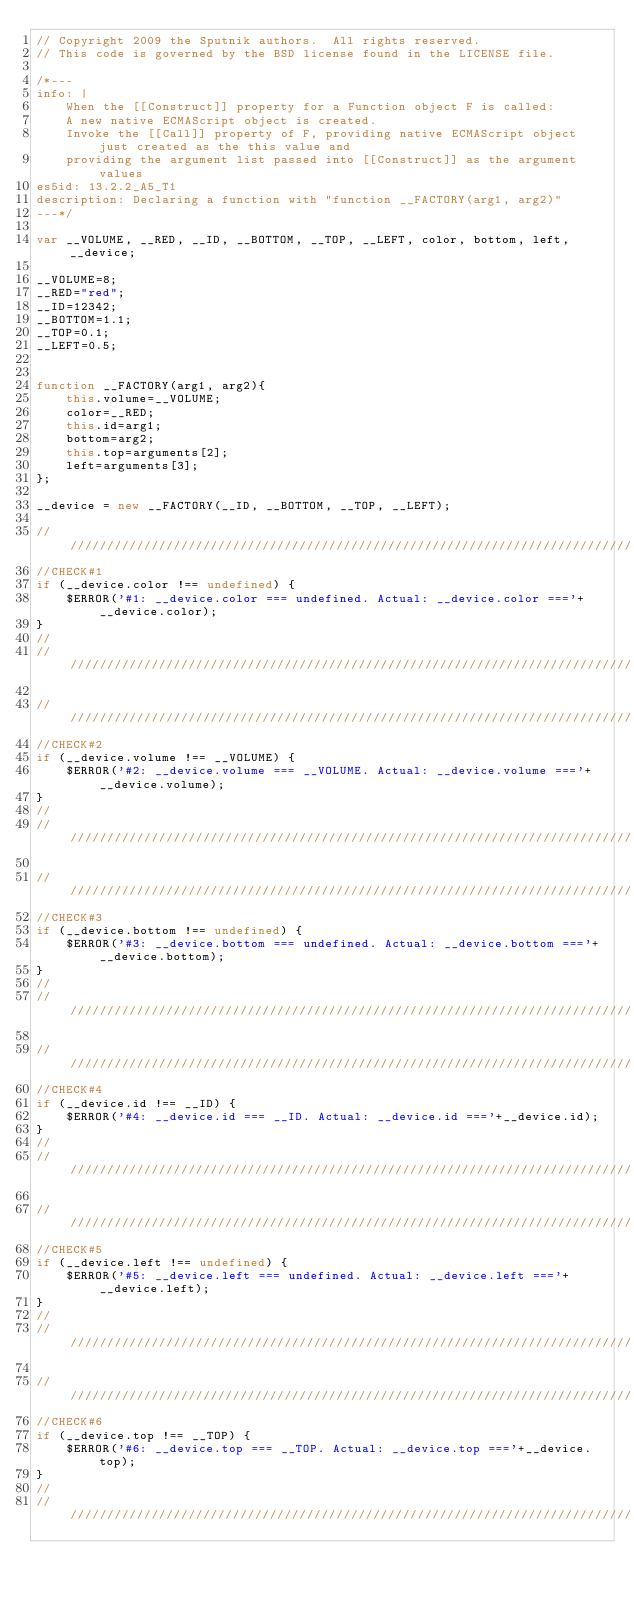Convert code to text. <code><loc_0><loc_0><loc_500><loc_500><_JavaScript_>// Copyright 2009 the Sputnik authors.  All rights reserved.
// This code is governed by the BSD license found in the LICENSE file.

/*---
info: |
    When the [[Construct]] property for a Function object F is called:
    A new native ECMAScript object is created.
    Invoke the [[Call]] property of F, providing native ECMAScript object just created as the this value and
    providing the argument list passed into [[Construct]] as the argument values
es5id: 13.2.2_A5_T1
description: Declaring a function with "function __FACTORY(arg1, arg2)"
---*/

var __VOLUME, __RED, __ID, __BOTTOM, __TOP, __LEFT, color, bottom, left, __device;

__VOLUME=8;
__RED="red";
__ID=12342;
__BOTTOM=1.1;
__TOP=0.1;
__LEFT=0.5;


function __FACTORY(arg1, arg2){
	this.volume=__VOLUME;
	color=__RED;
	this.id=arg1;
	bottom=arg2;
	this.top=arguments[2];
	left=arguments[3];
};

__device = new __FACTORY(__ID, __BOTTOM, __TOP, __LEFT);

//////////////////////////////////////////////////////////////////////////////
//CHECK#1
if (__device.color !== undefined) {
	$ERROR('#1: __device.color === undefined. Actual: __device.color ==='+__device.color);
}
//
//////////////////////////////////////////////////////////////////////////////

//////////////////////////////////////////////////////////////////////////////
//CHECK#2
if (__device.volume !== __VOLUME) {
	$ERROR('#2: __device.volume === __VOLUME. Actual: __device.volume ==='+__device.volume);
}
//
//////////////////////////////////////////////////////////////////////////////

//////////////////////////////////////////////////////////////////////////////
//CHECK#3
if (__device.bottom !== undefined) {
	$ERROR('#3: __device.bottom === undefined. Actual: __device.bottom ==='+__device.bottom);
}
//
//////////////////////////////////////////////////////////////////////////////

//////////////////////////////////////////////////////////////////////////////
//CHECK#4
if (__device.id !== __ID) {
	$ERROR('#4: __device.id === __ID. Actual: __device.id ==='+__device.id);
}
//
//////////////////////////////////////////////////////////////////////////////

//////////////////////////////////////////////////////////////////////////////
//CHECK#5
if (__device.left !== undefined) {
	$ERROR('#5: __device.left === undefined. Actual: __device.left ==='+__device.left);
}
//
//////////////////////////////////////////////////////////////////////////////

//////////////////////////////////////////////////////////////////////////////
//CHECK#6
if (__device.top !== __TOP) {
	$ERROR('#6: __device.top === __TOP. Actual: __device.top ==='+__device.top);
}
//
//////////////////////////////////////////////////////////////////////////////
</code> 